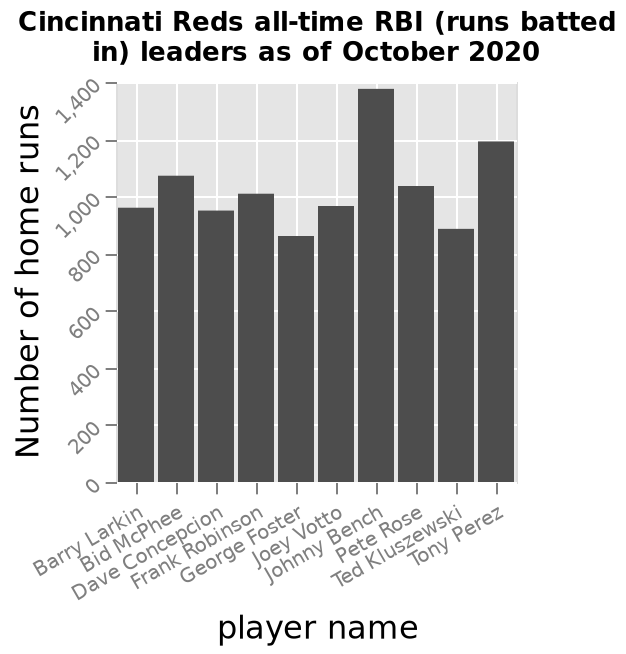<image>
Describe the following image in detail Here a bar diagram is labeled Cincinnati Reds all-time RBI (runs batted in) leaders as of October 2020. The x-axis plots player name while the y-axis shows Number of home runs. please summary the statistics and relations of the chart Most players scored between 800 and 1000 home runs, however, Johnny Bench scored the most at almost 1400. 